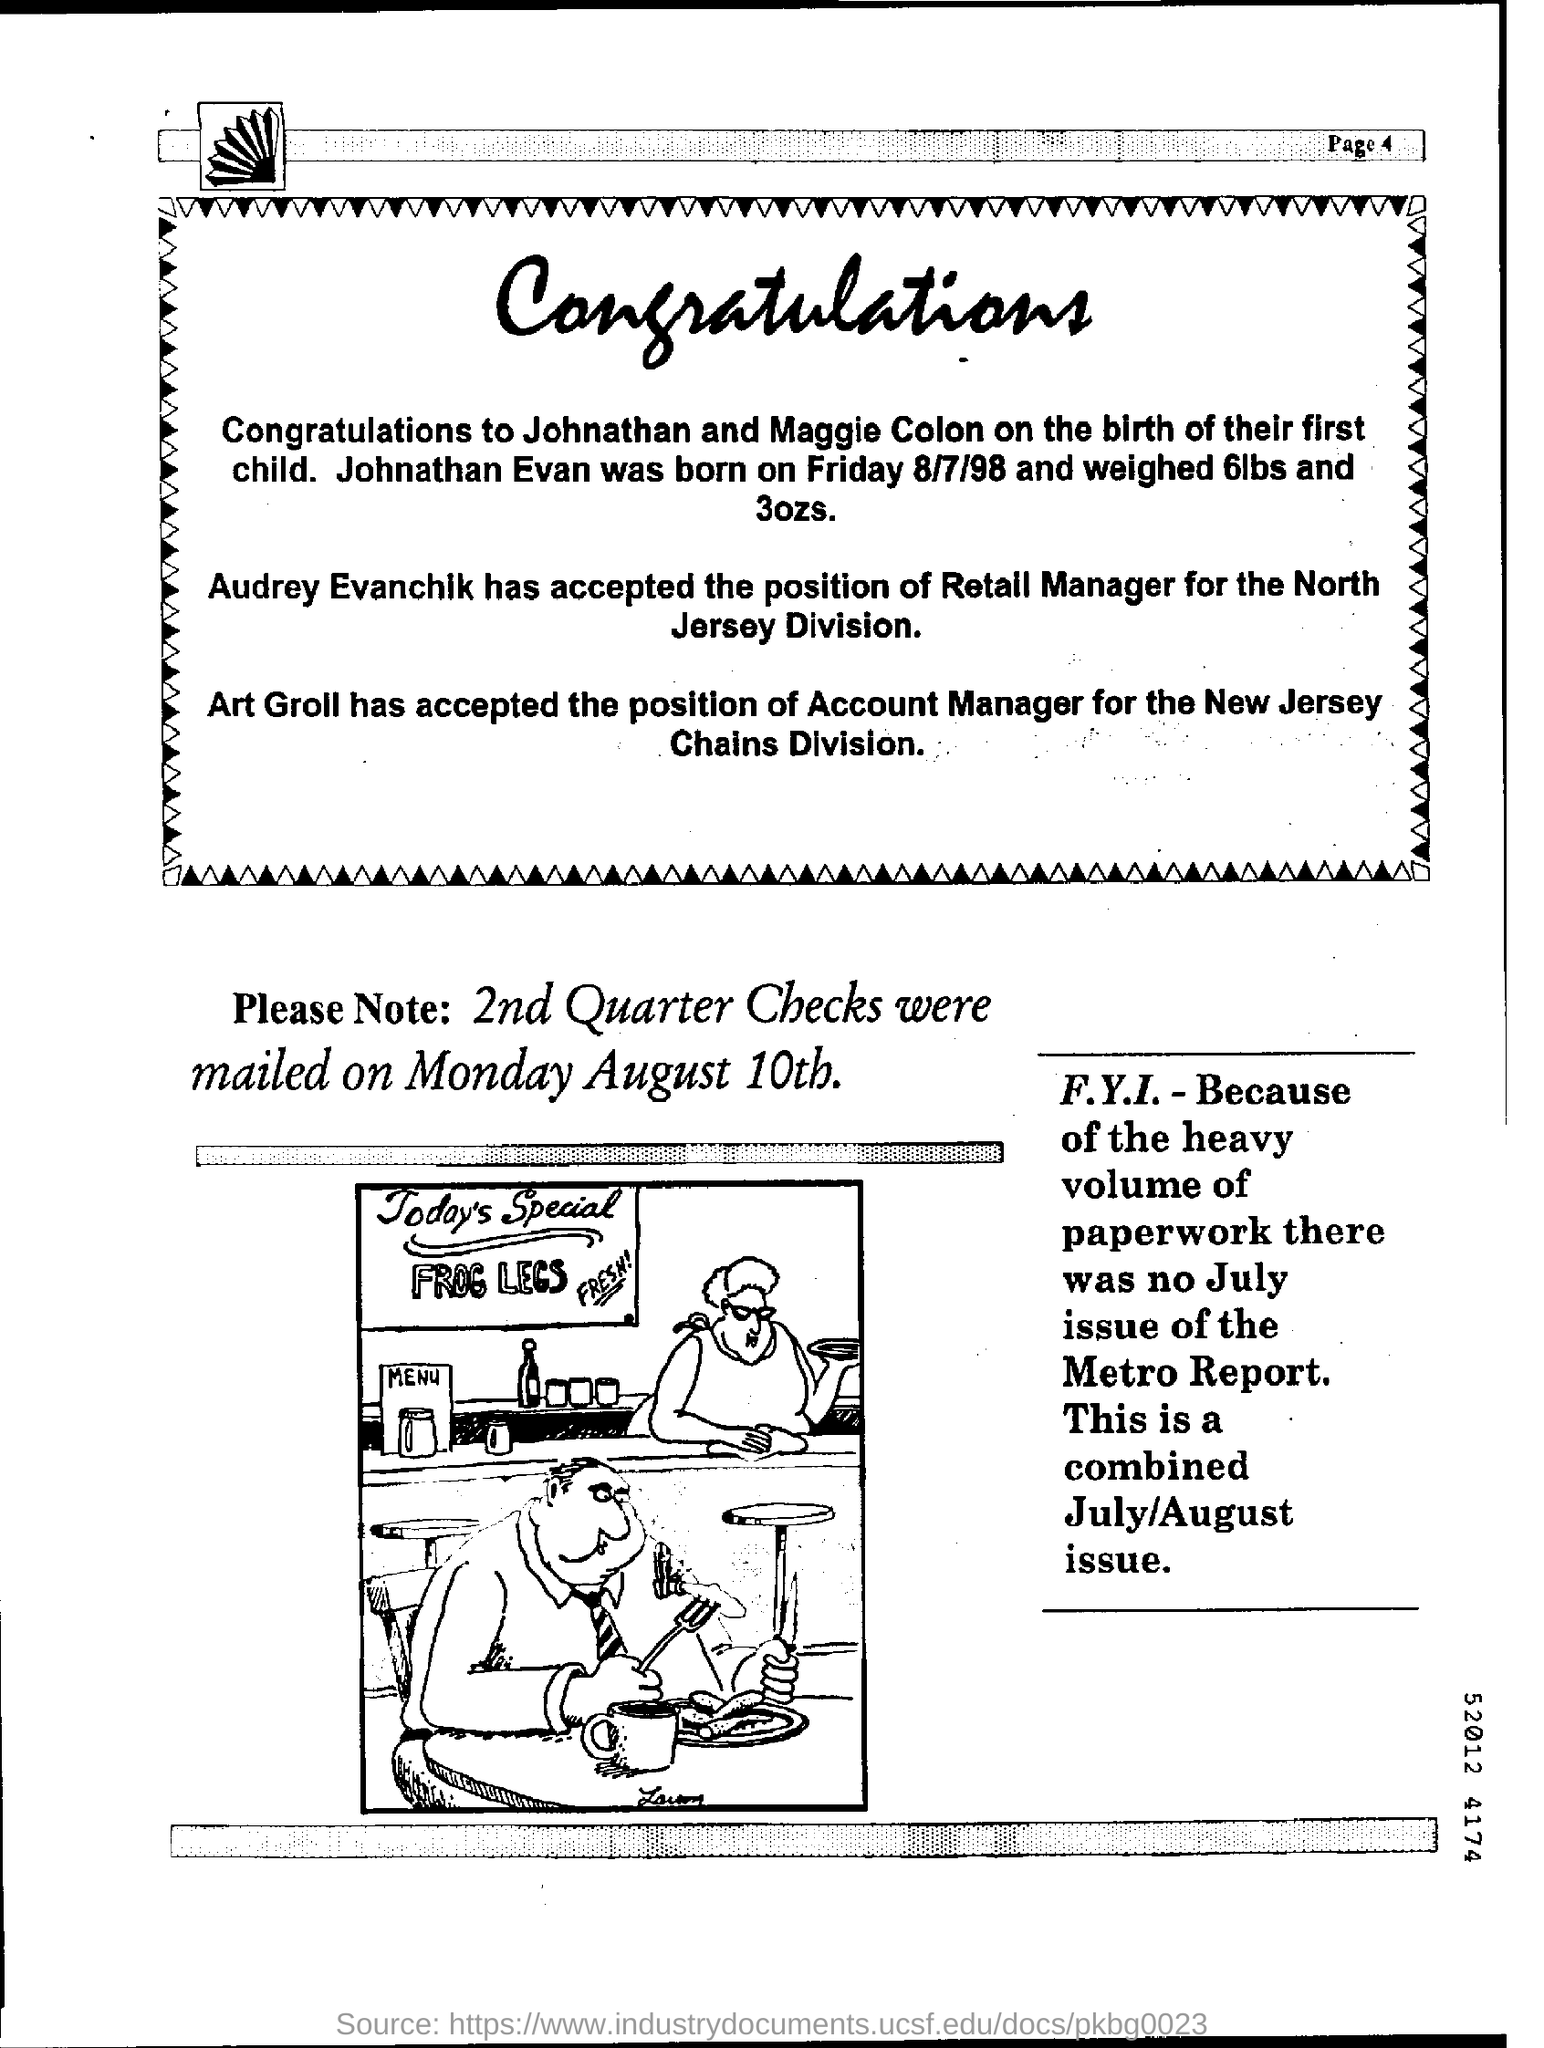List a handful of essential elements in this visual. Art Groll has accepted the position of Account Manager for the Chains Division. The position of retail manager for the North Jersey Division has been accepted by Audrey Evanchik. The second quarter checks were mailed on Monday, August 10th. On Friday, August 7th, 1998, Jonathan was born. Jonathan Evan weighed a total of 6lbs and 3Ozs. 